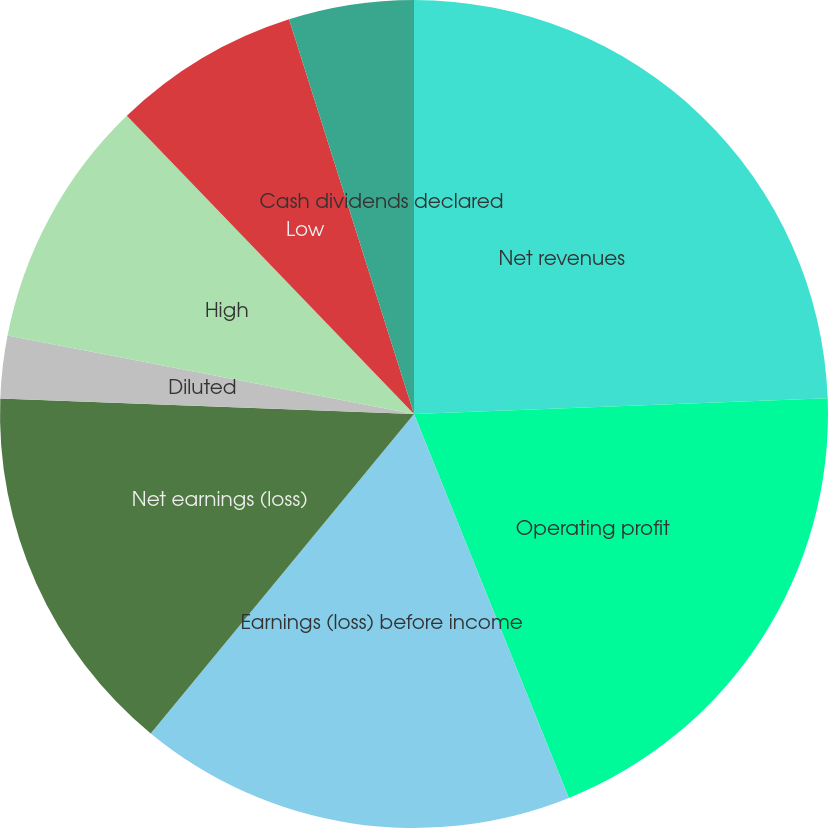Convert chart. <chart><loc_0><loc_0><loc_500><loc_500><pie_chart><fcel>Net revenues<fcel>Operating profit<fcel>Earnings (loss) before income<fcel>Net earnings (loss)<fcel>Basic<fcel>Diluted<fcel>High<fcel>Low<fcel>Cash dividends declared<nl><fcel>24.39%<fcel>19.51%<fcel>17.07%<fcel>14.63%<fcel>0.0%<fcel>2.44%<fcel>9.76%<fcel>7.32%<fcel>4.88%<nl></chart> 